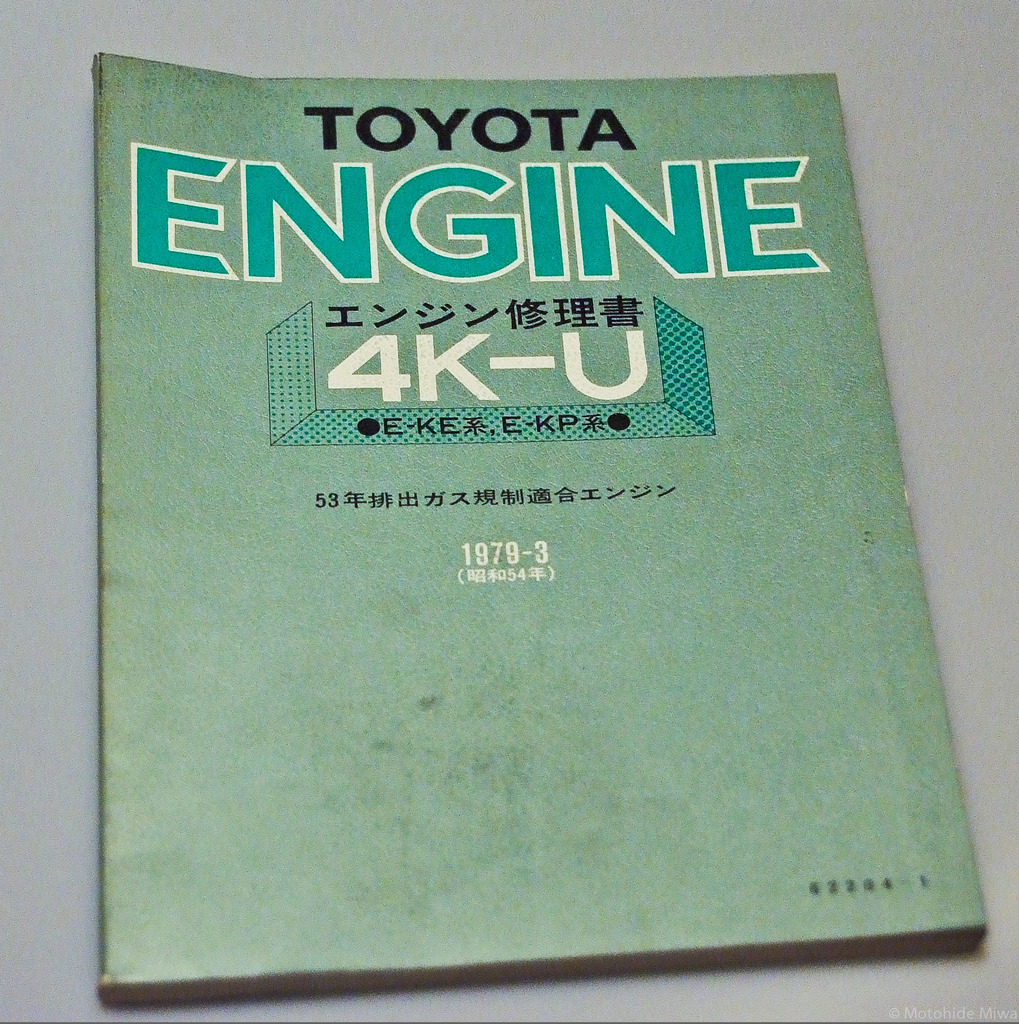Can you provide historical context on the importance of this manual in Toyota's history? Certainly! This manual not only represents the technological state of the late 1970s in Toyota's engine design but also serves as a document reflecting Toyota's commitment to providing comprehensive technical guidance to its service personnel and car owners. The 4K-U engine model, being one of the staples in Toyota’s lineup for compact cars, played a crucial role in establishing Toyota's reputation for dependable and economically efficient vehicles. This manual, therefore, stands as a testament to the era's automotive innovation and Toyota’s dedication to customer service and vehicle maintenance. 